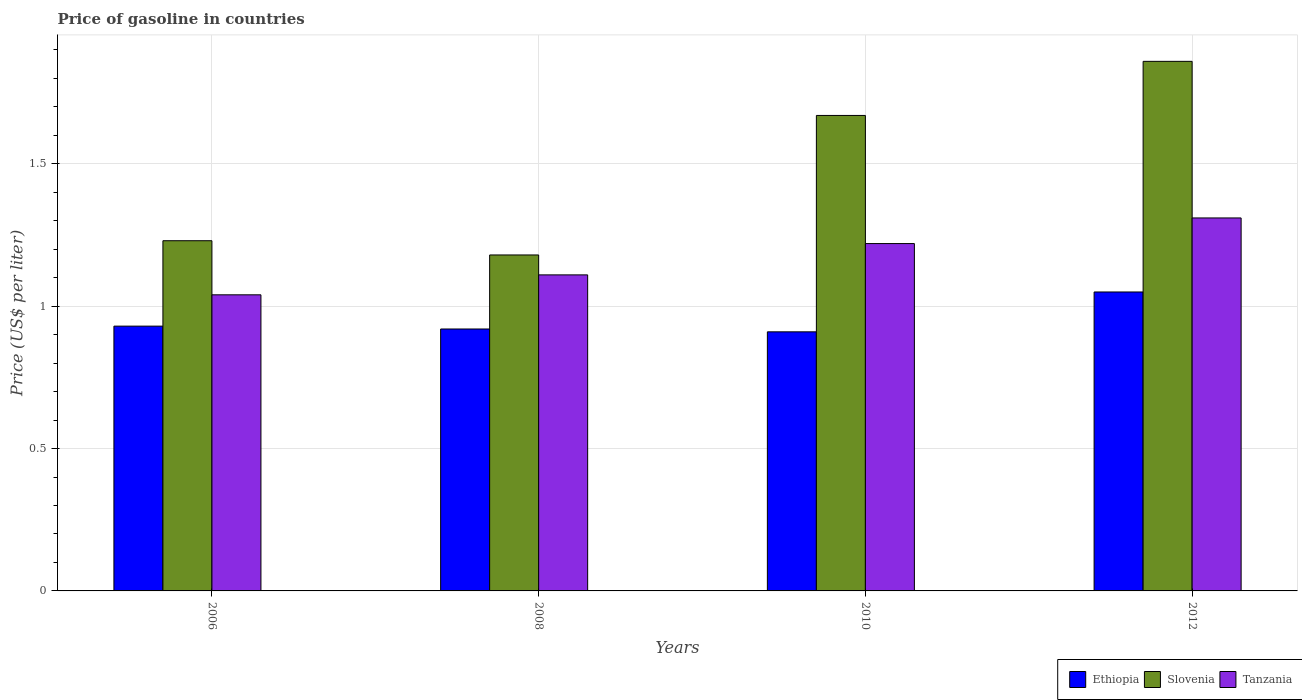How many different coloured bars are there?
Your response must be concise. 3. How many groups of bars are there?
Give a very brief answer. 4. Are the number of bars on each tick of the X-axis equal?
Keep it short and to the point. Yes. How many bars are there on the 2nd tick from the left?
Provide a short and direct response. 3. How many bars are there on the 2nd tick from the right?
Your answer should be very brief. 3. What is the label of the 3rd group of bars from the left?
Provide a succinct answer. 2010. What is the price of gasoline in Slovenia in 2008?
Ensure brevity in your answer.  1.18. Across all years, what is the maximum price of gasoline in Slovenia?
Your answer should be very brief. 1.86. Across all years, what is the minimum price of gasoline in Slovenia?
Provide a succinct answer. 1.18. What is the total price of gasoline in Tanzania in the graph?
Provide a short and direct response. 4.68. What is the difference between the price of gasoline in Ethiopia in 2006 and that in 2010?
Make the answer very short. 0.02. What is the difference between the price of gasoline in Slovenia in 2010 and the price of gasoline in Tanzania in 2006?
Provide a succinct answer. 0.63. What is the average price of gasoline in Slovenia per year?
Offer a very short reply. 1.49. In the year 2006, what is the difference between the price of gasoline in Slovenia and price of gasoline in Ethiopia?
Keep it short and to the point. 0.3. What is the ratio of the price of gasoline in Ethiopia in 2008 to that in 2010?
Your answer should be compact. 1.01. Is the difference between the price of gasoline in Slovenia in 2006 and 2008 greater than the difference between the price of gasoline in Ethiopia in 2006 and 2008?
Ensure brevity in your answer.  Yes. What is the difference between the highest and the second highest price of gasoline in Tanzania?
Keep it short and to the point. 0.09. What is the difference between the highest and the lowest price of gasoline in Tanzania?
Keep it short and to the point. 0.27. Is the sum of the price of gasoline in Ethiopia in 2010 and 2012 greater than the maximum price of gasoline in Slovenia across all years?
Ensure brevity in your answer.  Yes. What does the 2nd bar from the left in 2008 represents?
Keep it short and to the point. Slovenia. What does the 1st bar from the right in 2012 represents?
Give a very brief answer. Tanzania. How many bars are there?
Provide a succinct answer. 12. Are all the bars in the graph horizontal?
Your answer should be compact. No. How many years are there in the graph?
Your answer should be very brief. 4. Does the graph contain any zero values?
Offer a very short reply. No. How many legend labels are there?
Give a very brief answer. 3. How are the legend labels stacked?
Offer a very short reply. Horizontal. What is the title of the graph?
Provide a short and direct response. Price of gasoline in countries. Does "France" appear as one of the legend labels in the graph?
Offer a terse response. No. What is the label or title of the X-axis?
Your answer should be very brief. Years. What is the label or title of the Y-axis?
Give a very brief answer. Price (US$ per liter). What is the Price (US$ per liter) in Slovenia in 2006?
Provide a succinct answer. 1.23. What is the Price (US$ per liter) of Slovenia in 2008?
Your response must be concise. 1.18. What is the Price (US$ per liter) of Tanzania in 2008?
Make the answer very short. 1.11. What is the Price (US$ per liter) in Ethiopia in 2010?
Your answer should be compact. 0.91. What is the Price (US$ per liter) in Slovenia in 2010?
Provide a short and direct response. 1.67. What is the Price (US$ per liter) in Tanzania in 2010?
Provide a succinct answer. 1.22. What is the Price (US$ per liter) in Slovenia in 2012?
Provide a short and direct response. 1.86. What is the Price (US$ per liter) in Tanzania in 2012?
Your answer should be very brief. 1.31. Across all years, what is the maximum Price (US$ per liter) of Ethiopia?
Ensure brevity in your answer.  1.05. Across all years, what is the maximum Price (US$ per liter) of Slovenia?
Provide a succinct answer. 1.86. Across all years, what is the maximum Price (US$ per liter) of Tanzania?
Your response must be concise. 1.31. Across all years, what is the minimum Price (US$ per liter) in Ethiopia?
Offer a terse response. 0.91. Across all years, what is the minimum Price (US$ per liter) of Slovenia?
Offer a terse response. 1.18. Across all years, what is the minimum Price (US$ per liter) in Tanzania?
Ensure brevity in your answer.  1.04. What is the total Price (US$ per liter) of Ethiopia in the graph?
Keep it short and to the point. 3.81. What is the total Price (US$ per liter) in Slovenia in the graph?
Make the answer very short. 5.94. What is the total Price (US$ per liter) of Tanzania in the graph?
Your answer should be compact. 4.68. What is the difference between the Price (US$ per liter) of Ethiopia in 2006 and that in 2008?
Offer a very short reply. 0.01. What is the difference between the Price (US$ per liter) of Slovenia in 2006 and that in 2008?
Give a very brief answer. 0.05. What is the difference between the Price (US$ per liter) of Tanzania in 2006 and that in 2008?
Give a very brief answer. -0.07. What is the difference between the Price (US$ per liter) in Slovenia in 2006 and that in 2010?
Provide a short and direct response. -0.44. What is the difference between the Price (US$ per liter) in Tanzania in 2006 and that in 2010?
Offer a terse response. -0.18. What is the difference between the Price (US$ per liter) in Ethiopia in 2006 and that in 2012?
Keep it short and to the point. -0.12. What is the difference between the Price (US$ per liter) in Slovenia in 2006 and that in 2012?
Ensure brevity in your answer.  -0.63. What is the difference between the Price (US$ per liter) in Tanzania in 2006 and that in 2012?
Ensure brevity in your answer.  -0.27. What is the difference between the Price (US$ per liter) of Ethiopia in 2008 and that in 2010?
Give a very brief answer. 0.01. What is the difference between the Price (US$ per liter) of Slovenia in 2008 and that in 2010?
Provide a short and direct response. -0.49. What is the difference between the Price (US$ per liter) in Tanzania in 2008 and that in 2010?
Offer a terse response. -0.11. What is the difference between the Price (US$ per liter) of Ethiopia in 2008 and that in 2012?
Ensure brevity in your answer.  -0.13. What is the difference between the Price (US$ per liter) of Slovenia in 2008 and that in 2012?
Provide a short and direct response. -0.68. What is the difference between the Price (US$ per liter) in Tanzania in 2008 and that in 2012?
Provide a succinct answer. -0.2. What is the difference between the Price (US$ per liter) of Ethiopia in 2010 and that in 2012?
Ensure brevity in your answer.  -0.14. What is the difference between the Price (US$ per liter) of Slovenia in 2010 and that in 2012?
Offer a very short reply. -0.19. What is the difference between the Price (US$ per liter) in Tanzania in 2010 and that in 2012?
Your answer should be compact. -0.09. What is the difference between the Price (US$ per liter) in Ethiopia in 2006 and the Price (US$ per liter) in Slovenia in 2008?
Provide a succinct answer. -0.25. What is the difference between the Price (US$ per liter) in Ethiopia in 2006 and the Price (US$ per liter) in Tanzania in 2008?
Ensure brevity in your answer.  -0.18. What is the difference between the Price (US$ per liter) in Slovenia in 2006 and the Price (US$ per liter) in Tanzania in 2008?
Your response must be concise. 0.12. What is the difference between the Price (US$ per liter) of Ethiopia in 2006 and the Price (US$ per liter) of Slovenia in 2010?
Offer a terse response. -0.74. What is the difference between the Price (US$ per liter) in Ethiopia in 2006 and the Price (US$ per liter) in Tanzania in 2010?
Give a very brief answer. -0.29. What is the difference between the Price (US$ per liter) in Ethiopia in 2006 and the Price (US$ per liter) in Slovenia in 2012?
Your answer should be compact. -0.93. What is the difference between the Price (US$ per liter) of Ethiopia in 2006 and the Price (US$ per liter) of Tanzania in 2012?
Your answer should be very brief. -0.38. What is the difference between the Price (US$ per liter) of Slovenia in 2006 and the Price (US$ per liter) of Tanzania in 2012?
Offer a terse response. -0.08. What is the difference between the Price (US$ per liter) in Ethiopia in 2008 and the Price (US$ per liter) in Slovenia in 2010?
Keep it short and to the point. -0.75. What is the difference between the Price (US$ per liter) of Slovenia in 2008 and the Price (US$ per liter) of Tanzania in 2010?
Ensure brevity in your answer.  -0.04. What is the difference between the Price (US$ per liter) in Ethiopia in 2008 and the Price (US$ per liter) in Slovenia in 2012?
Provide a succinct answer. -0.94. What is the difference between the Price (US$ per liter) of Ethiopia in 2008 and the Price (US$ per liter) of Tanzania in 2012?
Your answer should be compact. -0.39. What is the difference between the Price (US$ per liter) in Slovenia in 2008 and the Price (US$ per liter) in Tanzania in 2012?
Your answer should be compact. -0.13. What is the difference between the Price (US$ per liter) in Ethiopia in 2010 and the Price (US$ per liter) in Slovenia in 2012?
Provide a succinct answer. -0.95. What is the difference between the Price (US$ per liter) in Slovenia in 2010 and the Price (US$ per liter) in Tanzania in 2012?
Provide a succinct answer. 0.36. What is the average Price (US$ per liter) of Ethiopia per year?
Your answer should be very brief. 0.95. What is the average Price (US$ per liter) of Slovenia per year?
Your response must be concise. 1.49. What is the average Price (US$ per liter) of Tanzania per year?
Provide a succinct answer. 1.17. In the year 2006, what is the difference between the Price (US$ per liter) in Ethiopia and Price (US$ per liter) in Tanzania?
Your answer should be compact. -0.11. In the year 2006, what is the difference between the Price (US$ per liter) in Slovenia and Price (US$ per liter) in Tanzania?
Offer a terse response. 0.19. In the year 2008, what is the difference between the Price (US$ per liter) of Ethiopia and Price (US$ per liter) of Slovenia?
Your answer should be compact. -0.26. In the year 2008, what is the difference between the Price (US$ per liter) in Ethiopia and Price (US$ per liter) in Tanzania?
Offer a very short reply. -0.19. In the year 2008, what is the difference between the Price (US$ per liter) in Slovenia and Price (US$ per liter) in Tanzania?
Provide a succinct answer. 0.07. In the year 2010, what is the difference between the Price (US$ per liter) of Ethiopia and Price (US$ per liter) of Slovenia?
Provide a short and direct response. -0.76. In the year 2010, what is the difference between the Price (US$ per liter) in Ethiopia and Price (US$ per liter) in Tanzania?
Offer a very short reply. -0.31. In the year 2010, what is the difference between the Price (US$ per liter) in Slovenia and Price (US$ per liter) in Tanzania?
Your answer should be compact. 0.45. In the year 2012, what is the difference between the Price (US$ per liter) of Ethiopia and Price (US$ per liter) of Slovenia?
Your answer should be very brief. -0.81. In the year 2012, what is the difference between the Price (US$ per liter) in Ethiopia and Price (US$ per liter) in Tanzania?
Provide a short and direct response. -0.26. In the year 2012, what is the difference between the Price (US$ per liter) of Slovenia and Price (US$ per liter) of Tanzania?
Offer a terse response. 0.55. What is the ratio of the Price (US$ per liter) in Ethiopia in 2006 to that in 2008?
Offer a very short reply. 1.01. What is the ratio of the Price (US$ per liter) of Slovenia in 2006 to that in 2008?
Your answer should be very brief. 1.04. What is the ratio of the Price (US$ per liter) of Tanzania in 2006 to that in 2008?
Your answer should be compact. 0.94. What is the ratio of the Price (US$ per liter) of Ethiopia in 2006 to that in 2010?
Your response must be concise. 1.02. What is the ratio of the Price (US$ per liter) in Slovenia in 2006 to that in 2010?
Offer a very short reply. 0.74. What is the ratio of the Price (US$ per liter) in Tanzania in 2006 to that in 2010?
Give a very brief answer. 0.85. What is the ratio of the Price (US$ per liter) in Ethiopia in 2006 to that in 2012?
Give a very brief answer. 0.89. What is the ratio of the Price (US$ per liter) of Slovenia in 2006 to that in 2012?
Your answer should be compact. 0.66. What is the ratio of the Price (US$ per liter) of Tanzania in 2006 to that in 2012?
Provide a short and direct response. 0.79. What is the ratio of the Price (US$ per liter) of Ethiopia in 2008 to that in 2010?
Offer a very short reply. 1.01. What is the ratio of the Price (US$ per liter) of Slovenia in 2008 to that in 2010?
Provide a succinct answer. 0.71. What is the ratio of the Price (US$ per liter) of Tanzania in 2008 to that in 2010?
Provide a short and direct response. 0.91. What is the ratio of the Price (US$ per liter) of Ethiopia in 2008 to that in 2012?
Provide a short and direct response. 0.88. What is the ratio of the Price (US$ per liter) in Slovenia in 2008 to that in 2012?
Your answer should be compact. 0.63. What is the ratio of the Price (US$ per liter) in Tanzania in 2008 to that in 2012?
Give a very brief answer. 0.85. What is the ratio of the Price (US$ per liter) of Ethiopia in 2010 to that in 2012?
Provide a short and direct response. 0.87. What is the ratio of the Price (US$ per liter) of Slovenia in 2010 to that in 2012?
Provide a short and direct response. 0.9. What is the ratio of the Price (US$ per liter) of Tanzania in 2010 to that in 2012?
Provide a short and direct response. 0.93. What is the difference between the highest and the second highest Price (US$ per liter) of Ethiopia?
Ensure brevity in your answer.  0.12. What is the difference between the highest and the second highest Price (US$ per liter) of Slovenia?
Give a very brief answer. 0.19. What is the difference between the highest and the second highest Price (US$ per liter) in Tanzania?
Offer a terse response. 0.09. What is the difference between the highest and the lowest Price (US$ per liter) in Ethiopia?
Provide a short and direct response. 0.14. What is the difference between the highest and the lowest Price (US$ per liter) of Slovenia?
Provide a short and direct response. 0.68. What is the difference between the highest and the lowest Price (US$ per liter) in Tanzania?
Keep it short and to the point. 0.27. 